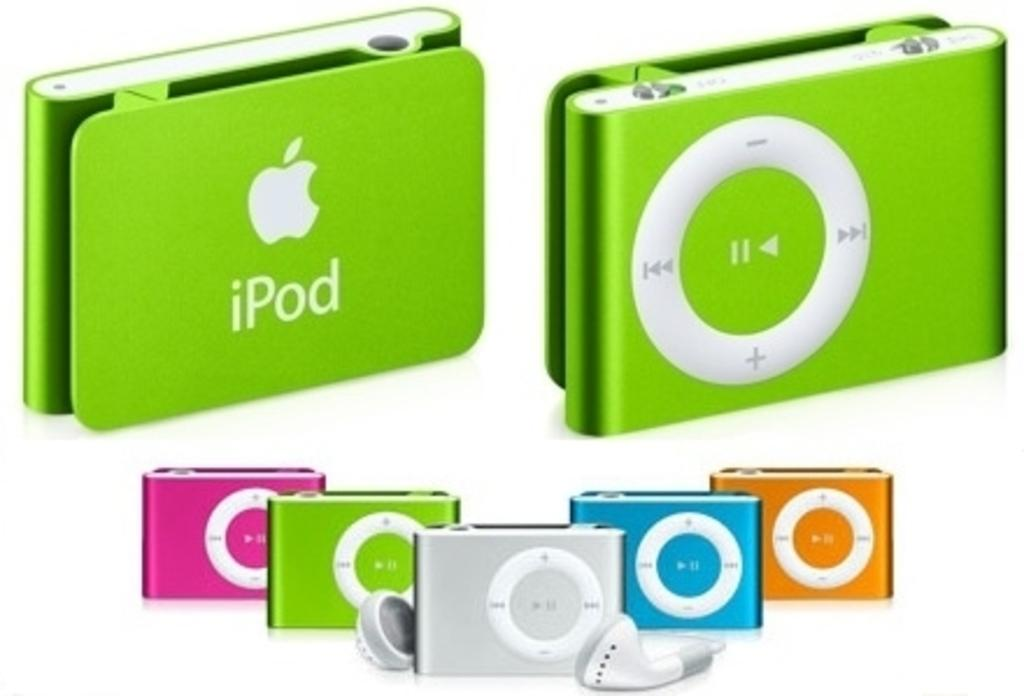What type of audio accessory is present in the image? There are headphones in the image. Can you describe the shape of the headphones? The headphones are rectangular in shape. What colors are the headphones available in? The headphones are in green, pink, and blue colors. How many goldfish are swimming in the skirt in the image? There are no goldfish or skirts present in the image. 